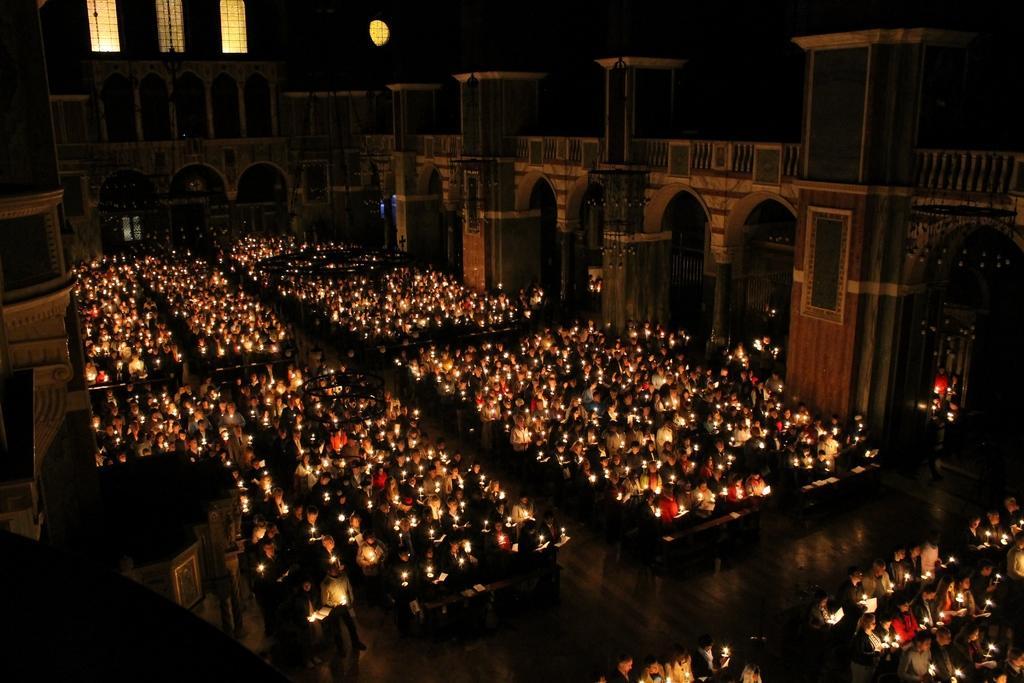How would you summarize this image in a sentence or two? In this image I can see the interior of the building in which I can see the floor and number of persons are standing on the floor holding candles in their hands. 